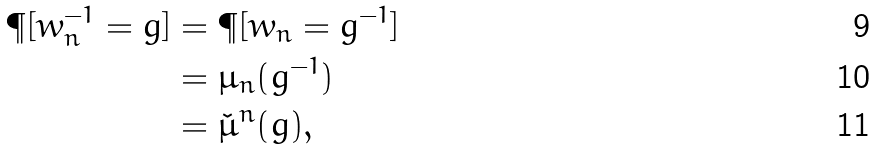Convert formula to latex. <formula><loc_0><loc_0><loc_500><loc_500>\P [ w _ { n } ^ { - 1 } = g ] & = \P [ w _ { n } = g ^ { - 1 } ] \\ & = \mu _ { n } ( g ^ { - 1 } ) \\ & = \check { \mu } ^ { n } ( g ) ,</formula> 